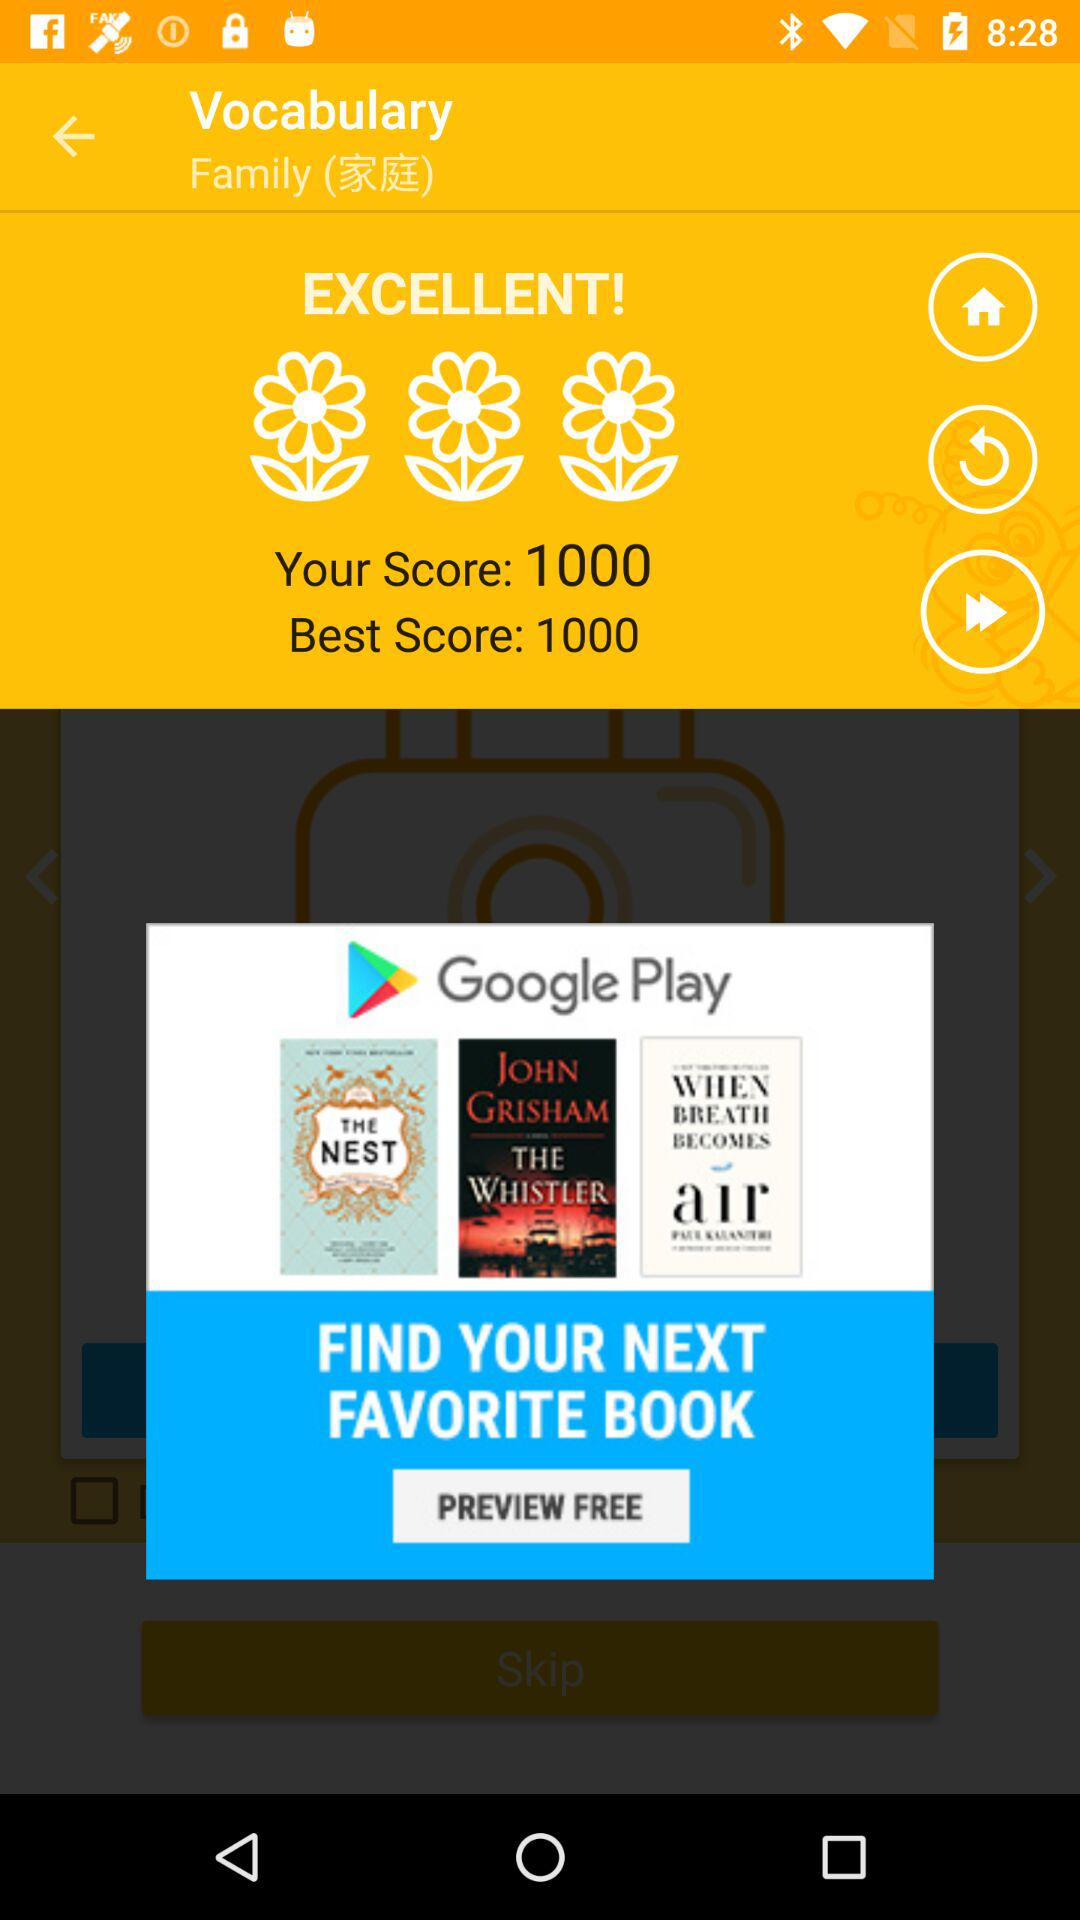What is the best score? The best score is 1000. 